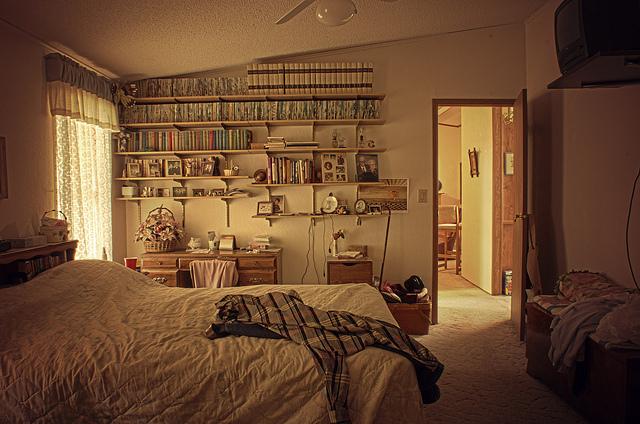How many pillows are on the bed?
Write a very short answer. 2. Is the dog on the bed?
Short answer required. No. Is this a hotel?
Quick response, please. No. Is this room elegant?
Answer briefly. No. What door is open?
Answer briefly. Bedroom. What is in the left-hand corner?
Short answer required. Bed. Has the bed been made?
Give a very brief answer. Yes. Is the door to the room open or closed?
Give a very brief answer. Open. Does the owner of this house appear to like books?
Short answer required. Yes. 